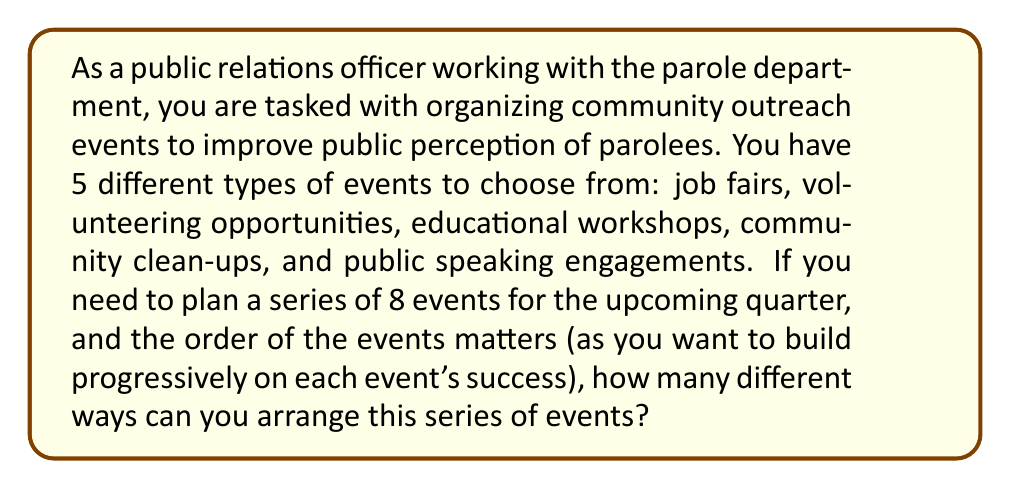Solve this math problem. To solve this problem, we need to use the concept of permutations with repetition. Here's why:

1. We are selecting 8 events in total.
2. We have 5 different types of events to choose from.
3. The order of events matters.
4. We can repeat event types (e.g., we could have multiple job fairs).

The formula for permutations with repetition is:

$$ n^r $$

Where:
$n$ = number of types of events to choose from
$r$ = number of events we're selecting

In this case:
$n = 5$ (types of events)
$r = 8$ (total events to be arranged)

Plugging these values into our formula:

$$ 5^8 $$

To calculate this:

$$ 5^8 = 5 \times 5 \times 5 \times 5 \times 5 \times 5 \times 5 \times 5 = 390,625 $$

Therefore, there are 390,625 different ways to arrange this series of 8 events.
Answer: 390,625 